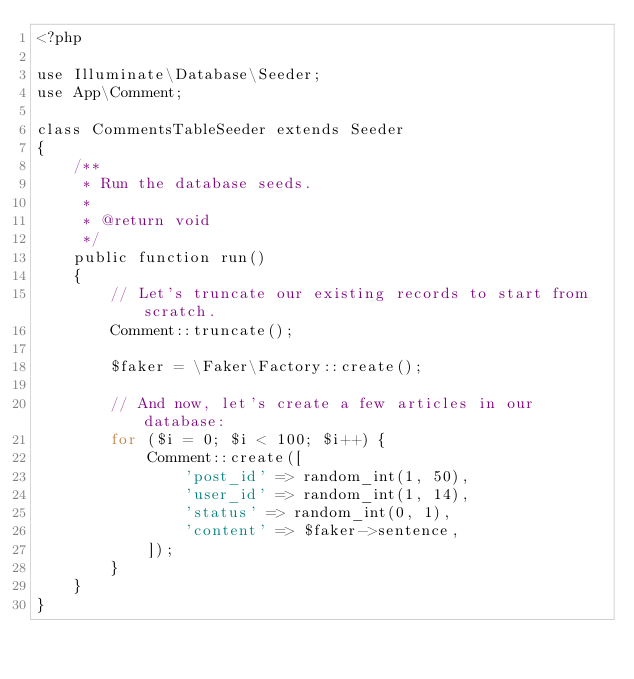Convert code to text. <code><loc_0><loc_0><loc_500><loc_500><_PHP_><?php

use Illuminate\Database\Seeder;
use App\Comment;

class CommentsTableSeeder extends Seeder
{
    /**
     * Run the database seeds.
     *
     * @return void
     */
    public function run()
    {
        // Let's truncate our existing records to start from scratch.
        Comment::truncate();

        $faker = \Faker\Factory::create();

        // And now, let's create a few articles in our database:
        for ($i = 0; $i < 100; $i++) {
            Comment::create([
                'post_id' => random_int(1, 50),
                'user_id' => random_int(1, 14),
                'status' => random_int(0, 1),
                'content' => $faker->sentence,
            ]);
        }
    }
}
</code> 